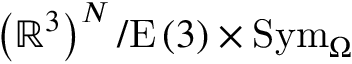<formula> <loc_0><loc_0><loc_500><loc_500>\left ( \mathbb { R } ^ { 3 } \right ) ^ { N } / E \left ( 3 \right ) \times S y m _ { \Omega }</formula> 